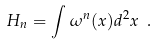<formula> <loc_0><loc_0><loc_500><loc_500>H _ { n } = \int \omega ^ { n } ( { x } ) d ^ { 2 } x \ .</formula> 